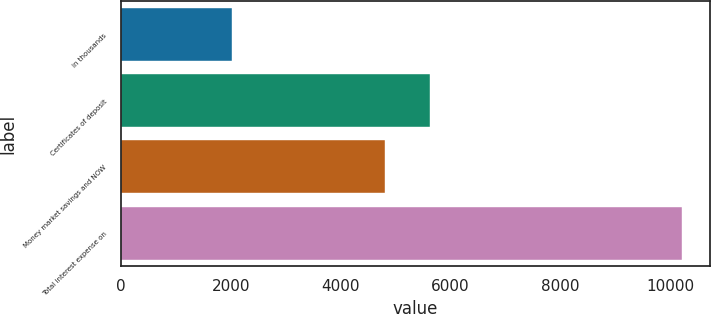Convert chart. <chart><loc_0><loc_0><loc_500><loc_500><bar_chart><fcel>in thousands<fcel>Certificates of deposit<fcel>Money market savings and NOW<fcel>Total interest expense on<nl><fcel>2016<fcel>5636.2<fcel>4816<fcel>10218<nl></chart> 